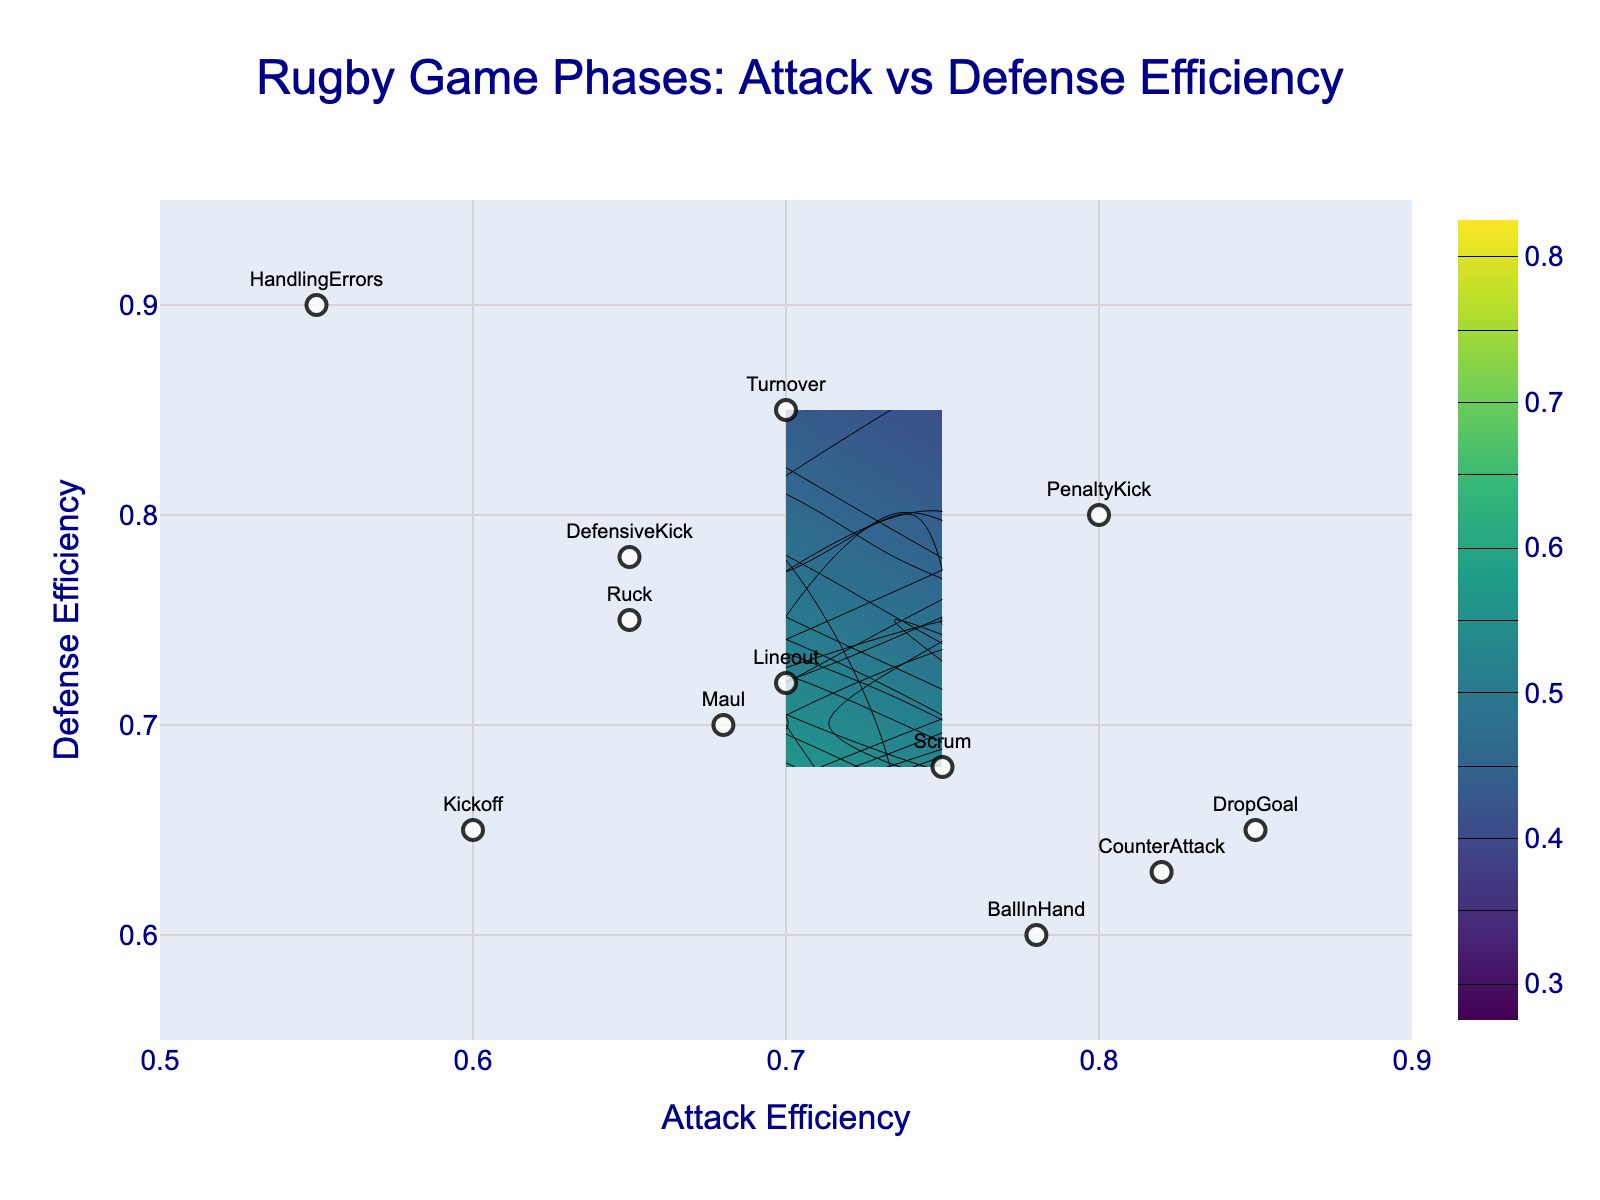What is the title of the figure? The title can be found at the top of the figure. It is usually written in a larger and bold font.
Answer: Rugby Game Phases: Attack vs Defense Efficiency What are the ranges of the x-axis and y-axis? Check the scale on the x-axis and y-axis. The x-axis ranges from 0.5 to 0.9 and the y-axis ranges from 0.55 to 0.95.
Answer: x-axis: 0.5 to 0.9, y-axis: 0.55 to 0.95 Which game phase has the highest attack efficiency? Look for the highest value on the x-axis where the corresponding game phase label is attached.
Answer: DropGoal What is the defense efficiency of the 'HandlingErrors' phase? Find the 'HandlingErrors' label on the plot and check its corresponding value on the y-axis.
Answer: 0.90 Which game phase has equal values for both attack and defense efficiencies? Look for a point where the x and y values are the same, and identify the game phase label.
Answer: PenaltyKick Which game phases have a higher attack efficiency than 'DropGoal'? No game phase has a higher attack efficiency than 'DropGoal' given it has the highest value of 0.85.
Answer: None What is the total range of the contour map shown in the figure? The range is defined by the start and end values of the contours. Check the contour specifications. Contours start at 0.3 and end at 0.8.
Answer: 0.5 Which game phases fall within the range where both attack and defense efficiency are between 0.6 and 0.7? Identify game phases within the specified efficiency range by locating labels positioned within x between 0.6 and 0.7 and y between 0.6 and 0.7.
Answer: Kickoff, Maul 